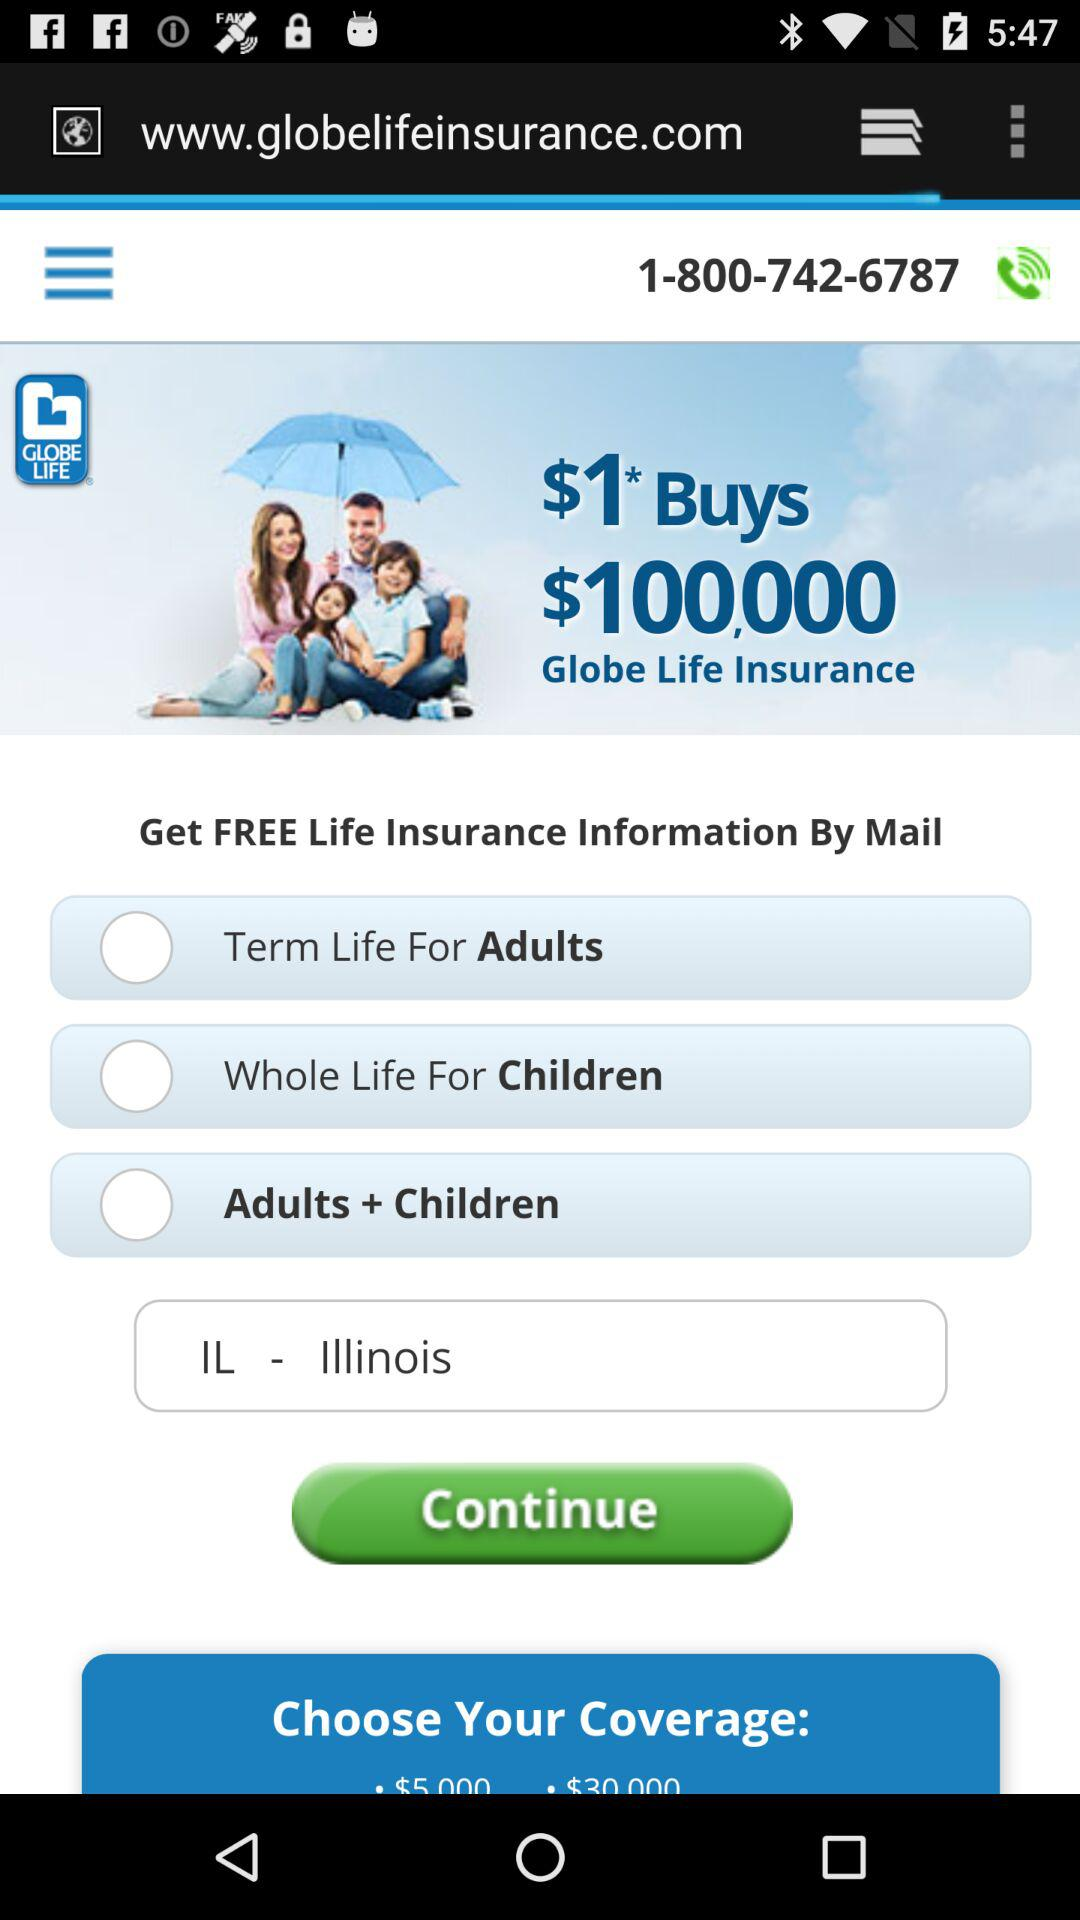How many coverage options are there? Based on the image, there are three coverage options available: 'Term Life For Adults,' 'Whole Life For Children,' and 'Adults + Children.' 